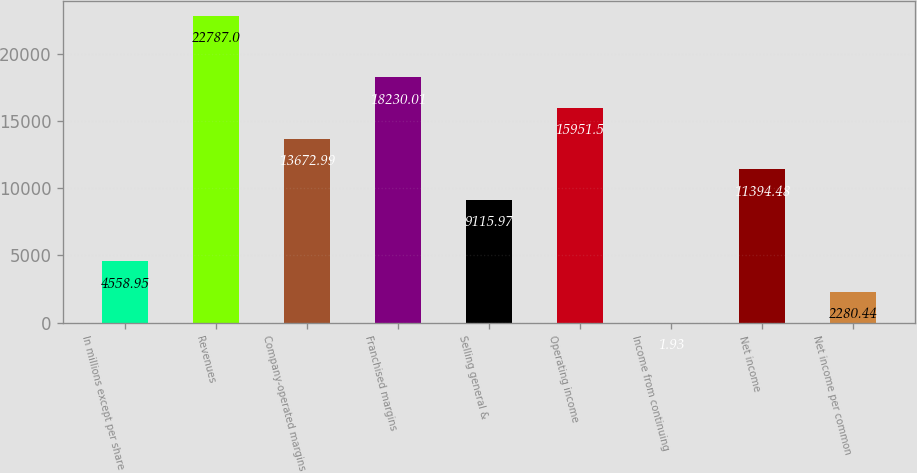Convert chart to OTSL. <chart><loc_0><loc_0><loc_500><loc_500><bar_chart><fcel>In millions except per share<fcel>Revenues<fcel>Company-operated margins<fcel>Franchised margins<fcel>Selling general &<fcel>Operating income<fcel>Income from continuing<fcel>Net income<fcel>Net income per common<nl><fcel>4558.95<fcel>22787<fcel>13673<fcel>18230<fcel>9115.97<fcel>15951.5<fcel>1.93<fcel>11394.5<fcel>2280.44<nl></chart> 